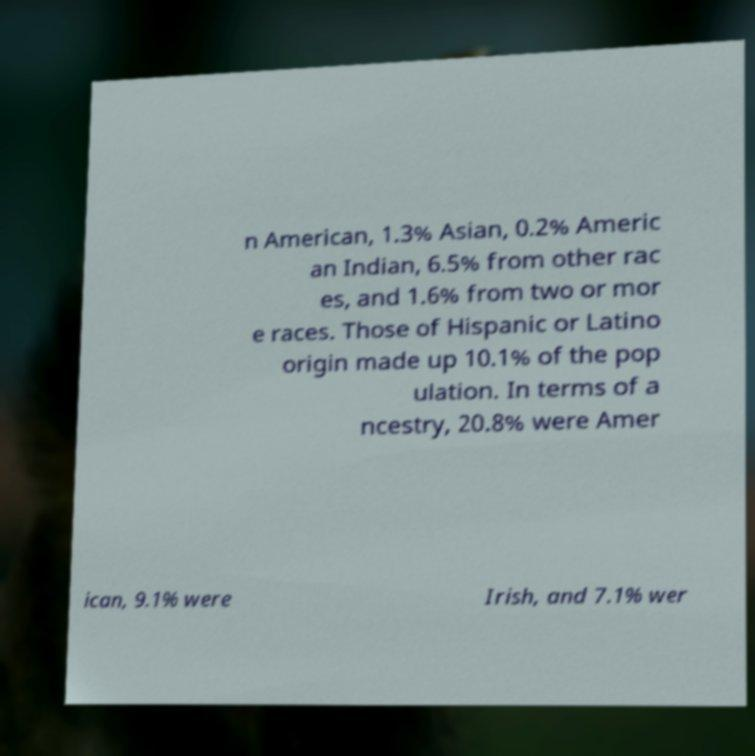What messages or text are displayed in this image? I need them in a readable, typed format. n American, 1.3% Asian, 0.2% Americ an Indian, 6.5% from other rac es, and 1.6% from two or mor e races. Those of Hispanic or Latino origin made up 10.1% of the pop ulation. In terms of a ncestry, 20.8% were Amer ican, 9.1% were Irish, and 7.1% wer 